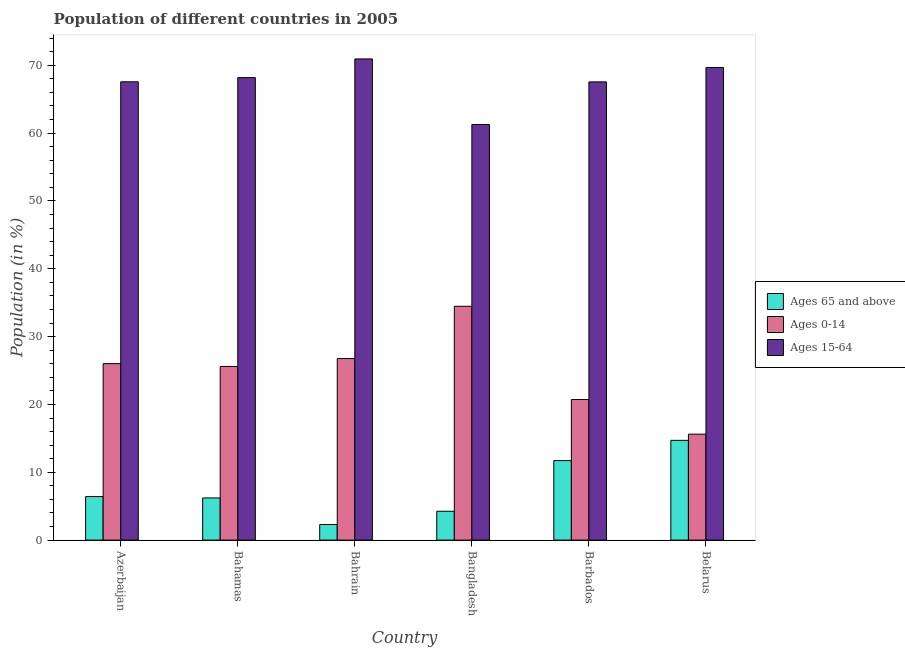How many different coloured bars are there?
Your answer should be very brief. 3. How many groups of bars are there?
Your answer should be compact. 6. Are the number of bars on each tick of the X-axis equal?
Your answer should be very brief. Yes. How many bars are there on the 3rd tick from the left?
Offer a terse response. 3. What is the label of the 1st group of bars from the left?
Keep it short and to the point. Azerbaijan. What is the percentage of population within the age-group 15-64 in Belarus?
Your response must be concise. 69.68. Across all countries, what is the maximum percentage of population within the age-group of 65 and above?
Your answer should be compact. 14.71. Across all countries, what is the minimum percentage of population within the age-group 0-14?
Make the answer very short. 15.62. In which country was the percentage of population within the age-group of 65 and above minimum?
Your answer should be compact. Bahrain. What is the total percentage of population within the age-group of 65 and above in the graph?
Provide a succinct answer. 45.62. What is the difference between the percentage of population within the age-group 0-14 in Bangladesh and that in Barbados?
Make the answer very short. 13.75. What is the difference between the percentage of population within the age-group of 65 and above in Bahamas and the percentage of population within the age-group 15-64 in Azerbaijan?
Your answer should be compact. -61.35. What is the average percentage of population within the age-group 15-64 per country?
Your answer should be very brief. 67.53. What is the difference between the percentage of population within the age-group of 65 and above and percentage of population within the age-group 0-14 in Barbados?
Give a very brief answer. -9.01. What is the ratio of the percentage of population within the age-group 0-14 in Bahamas to that in Belarus?
Provide a succinct answer. 1.64. Is the difference between the percentage of population within the age-group of 65 and above in Azerbaijan and Bangladesh greater than the difference between the percentage of population within the age-group 0-14 in Azerbaijan and Bangladesh?
Make the answer very short. Yes. What is the difference between the highest and the second highest percentage of population within the age-group of 65 and above?
Offer a very short reply. 2.99. What is the difference between the highest and the lowest percentage of population within the age-group of 65 and above?
Offer a very short reply. 12.41. In how many countries, is the percentage of population within the age-group 0-14 greater than the average percentage of population within the age-group 0-14 taken over all countries?
Offer a terse response. 4. Is the sum of the percentage of population within the age-group 15-64 in Azerbaijan and Bahamas greater than the maximum percentage of population within the age-group 0-14 across all countries?
Provide a short and direct response. Yes. What does the 2nd bar from the left in Bahamas represents?
Make the answer very short. Ages 0-14. What does the 1st bar from the right in Bangladesh represents?
Your answer should be compact. Ages 15-64. What is the difference between two consecutive major ticks on the Y-axis?
Give a very brief answer. 10. How are the legend labels stacked?
Offer a very short reply. Vertical. What is the title of the graph?
Offer a very short reply. Population of different countries in 2005. What is the label or title of the Y-axis?
Your answer should be compact. Population (in %). What is the Population (in %) of Ages 65 and above in Azerbaijan?
Offer a terse response. 6.42. What is the Population (in %) of Ages 0-14 in Azerbaijan?
Provide a short and direct response. 26.01. What is the Population (in %) of Ages 15-64 in Azerbaijan?
Keep it short and to the point. 67.57. What is the Population (in %) in Ages 65 and above in Bahamas?
Give a very brief answer. 6.22. What is the Population (in %) of Ages 0-14 in Bahamas?
Give a very brief answer. 25.6. What is the Population (in %) of Ages 15-64 in Bahamas?
Provide a short and direct response. 68.18. What is the Population (in %) in Ages 65 and above in Bahrain?
Keep it short and to the point. 2.3. What is the Population (in %) of Ages 0-14 in Bahrain?
Your response must be concise. 26.77. What is the Population (in %) in Ages 15-64 in Bahrain?
Offer a very short reply. 70.94. What is the Population (in %) in Ages 65 and above in Bangladesh?
Provide a short and direct response. 4.25. What is the Population (in %) of Ages 0-14 in Bangladesh?
Your answer should be compact. 34.47. What is the Population (in %) in Ages 15-64 in Bangladesh?
Ensure brevity in your answer.  61.27. What is the Population (in %) of Ages 65 and above in Barbados?
Provide a succinct answer. 11.72. What is the Population (in %) in Ages 0-14 in Barbados?
Ensure brevity in your answer.  20.73. What is the Population (in %) of Ages 15-64 in Barbados?
Give a very brief answer. 67.55. What is the Population (in %) in Ages 65 and above in Belarus?
Make the answer very short. 14.71. What is the Population (in %) in Ages 0-14 in Belarus?
Give a very brief answer. 15.62. What is the Population (in %) of Ages 15-64 in Belarus?
Offer a very short reply. 69.68. Across all countries, what is the maximum Population (in %) of Ages 65 and above?
Provide a succinct answer. 14.71. Across all countries, what is the maximum Population (in %) in Ages 0-14?
Provide a short and direct response. 34.47. Across all countries, what is the maximum Population (in %) in Ages 15-64?
Make the answer very short. 70.94. Across all countries, what is the minimum Population (in %) of Ages 65 and above?
Your response must be concise. 2.3. Across all countries, what is the minimum Population (in %) in Ages 0-14?
Your response must be concise. 15.62. Across all countries, what is the minimum Population (in %) in Ages 15-64?
Offer a terse response. 61.27. What is the total Population (in %) of Ages 65 and above in the graph?
Ensure brevity in your answer.  45.62. What is the total Population (in %) of Ages 0-14 in the graph?
Provide a succinct answer. 149.19. What is the total Population (in %) in Ages 15-64 in the graph?
Your answer should be compact. 405.19. What is the difference between the Population (in %) of Ages 65 and above in Azerbaijan and that in Bahamas?
Offer a very short reply. 0.2. What is the difference between the Population (in %) of Ages 0-14 in Azerbaijan and that in Bahamas?
Keep it short and to the point. 0.41. What is the difference between the Population (in %) of Ages 15-64 in Azerbaijan and that in Bahamas?
Make the answer very short. -0.62. What is the difference between the Population (in %) of Ages 65 and above in Azerbaijan and that in Bahrain?
Your answer should be very brief. 4.12. What is the difference between the Population (in %) of Ages 0-14 in Azerbaijan and that in Bahrain?
Give a very brief answer. -0.76. What is the difference between the Population (in %) in Ages 15-64 in Azerbaijan and that in Bahrain?
Give a very brief answer. -3.37. What is the difference between the Population (in %) in Ages 65 and above in Azerbaijan and that in Bangladesh?
Your answer should be very brief. 2.17. What is the difference between the Population (in %) of Ages 0-14 in Azerbaijan and that in Bangladesh?
Give a very brief answer. -8.46. What is the difference between the Population (in %) in Ages 15-64 in Azerbaijan and that in Bangladesh?
Offer a very short reply. 6.29. What is the difference between the Population (in %) of Ages 65 and above in Azerbaijan and that in Barbados?
Offer a terse response. -5.3. What is the difference between the Population (in %) of Ages 0-14 in Azerbaijan and that in Barbados?
Offer a very short reply. 5.28. What is the difference between the Population (in %) in Ages 15-64 in Azerbaijan and that in Barbados?
Offer a terse response. 0.01. What is the difference between the Population (in %) of Ages 65 and above in Azerbaijan and that in Belarus?
Give a very brief answer. -8.29. What is the difference between the Population (in %) of Ages 0-14 in Azerbaijan and that in Belarus?
Ensure brevity in your answer.  10.39. What is the difference between the Population (in %) of Ages 15-64 in Azerbaijan and that in Belarus?
Provide a short and direct response. -2.11. What is the difference between the Population (in %) of Ages 65 and above in Bahamas and that in Bahrain?
Offer a very short reply. 3.92. What is the difference between the Population (in %) in Ages 0-14 in Bahamas and that in Bahrain?
Give a very brief answer. -1.17. What is the difference between the Population (in %) in Ages 15-64 in Bahamas and that in Bahrain?
Ensure brevity in your answer.  -2.75. What is the difference between the Population (in %) of Ages 65 and above in Bahamas and that in Bangladesh?
Provide a short and direct response. 1.96. What is the difference between the Population (in %) of Ages 0-14 in Bahamas and that in Bangladesh?
Your response must be concise. -8.87. What is the difference between the Population (in %) of Ages 15-64 in Bahamas and that in Bangladesh?
Your response must be concise. 6.91. What is the difference between the Population (in %) of Ages 65 and above in Bahamas and that in Barbados?
Provide a succinct answer. -5.5. What is the difference between the Population (in %) of Ages 0-14 in Bahamas and that in Barbados?
Ensure brevity in your answer.  4.87. What is the difference between the Population (in %) in Ages 15-64 in Bahamas and that in Barbados?
Keep it short and to the point. 0.63. What is the difference between the Population (in %) in Ages 65 and above in Bahamas and that in Belarus?
Provide a short and direct response. -8.49. What is the difference between the Population (in %) in Ages 0-14 in Bahamas and that in Belarus?
Ensure brevity in your answer.  9.98. What is the difference between the Population (in %) in Ages 15-64 in Bahamas and that in Belarus?
Ensure brevity in your answer.  -1.49. What is the difference between the Population (in %) in Ages 65 and above in Bahrain and that in Bangladesh?
Offer a terse response. -1.96. What is the difference between the Population (in %) in Ages 0-14 in Bahrain and that in Bangladesh?
Your response must be concise. -7.71. What is the difference between the Population (in %) in Ages 15-64 in Bahrain and that in Bangladesh?
Keep it short and to the point. 9.66. What is the difference between the Population (in %) in Ages 65 and above in Bahrain and that in Barbados?
Make the answer very short. -9.42. What is the difference between the Population (in %) of Ages 0-14 in Bahrain and that in Barbados?
Your response must be concise. 6.04. What is the difference between the Population (in %) in Ages 15-64 in Bahrain and that in Barbados?
Your response must be concise. 3.38. What is the difference between the Population (in %) in Ages 65 and above in Bahrain and that in Belarus?
Offer a very short reply. -12.41. What is the difference between the Population (in %) of Ages 0-14 in Bahrain and that in Belarus?
Provide a short and direct response. 11.15. What is the difference between the Population (in %) of Ages 15-64 in Bahrain and that in Belarus?
Provide a short and direct response. 1.26. What is the difference between the Population (in %) in Ages 65 and above in Bangladesh and that in Barbados?
Provide a succinct answer. -7.47. What is the difference between the Population (in %) in Ages 0-14 in Bangladesh and that in Barbados?
Your response must be concise. 13.75. What is the difference between the Population (in %) of Ages 15-64 in Bangladesh and that in Barbados?
Provide a succinct answer. -6.28. What is the difference between the Population (in %) in Ages 65 and above in Bangladesh and that in Belarus?
Your response must be concise. -10.45. What is the difference between the Population (in %) of Ages 0-14 in Bangladesh and that in Belarus?
Give a very brief answer. 18.86. What is the difference between the Population (in %) in Ages 15-64 in Bangladesh and that in Belarus?
Give a very brief answer. -8.4. What is the difference between the Population (in %) in Ages 65 and above in Barbados and that in Belarus?
Provide a short and direct response. -2.99. What is the difference between the Population (in %) of Ages 0-14 in Barbados and that in Belarus?
Your answer should be very brief. 5.11. What is the difference between the Population (in %) of Ages 15-64 in Barbados and that in Belarus?
Ensure brevity in your answer.  -2.12. What is the difference between the Population (in %) of Ages 65 and above in Azerbaijan and the Population (in %) of Ages 0-14 in Bahamas?
Make the answer very short. -19.18. What is the difference between the Population (in %) in Ages 65 and above in Azerbaijan and the Population (in %) in Ages 15-64 in Bahamas?
Offer a very short reply. -61.76. What is the difference between the Population (in %) in Ages 0-14 in Azerbaijan and the Population (in %) in Ages 15-64 in Bahamas?
Make the answer very short. -42.17. What is the difference between the Population (in %) in Ages 65 and above in Azerbaijan and the Population (in %) in Ages 0-14 in Bahrain?
Give a very brief answer. -20.35. What is the difference between the Population (in %) in Ages 65 and above in Azerbaijan and the Population (in %) in Ages 15-64 in Bahrain?
Provide a succinct answer. -64.52. What is the difference between the Population (in %) of Ages 0-14 in Azerbaijan and the Population (in %) of Ages 15-64 in Bahrain?
Your answer should be compact. -44.93. What is the difference between the Population (in %) in Ages 65 and above in Azerbaijan and the Population (in %) in Ages 0-14 in Bangladesh?
Your answer should be very brief. -28.05. What is the difference between the Population (in %) of Ages 65 and above in Azerbaijan and the Population (in %) of Ages 15-64 in Bangladesh?
Your answer should be very brief. -54.85. What is the difference between the Population (in %) in Ages 0-14 in Azerbaijan and the Population (in %) in Ages 15-64 in Bangladesh?
Provide a succinct answer. -35.26. What is the difference between the Population (in %) of Ages 65 and above in Azerbaijan and the Population (in %) of Ages 0-14 in Barbados?
Provide a succinct answer. -14.31. What is the difference between the Population (in %) of Ages 65 and above in Azerbaijan and the Population (in %) of Ages 15-64 in Barbados?
Make the answer very short. -61.13. What is the difference between the Population (in %) in Ages 0-14 in Azerbaijan and the Population (in %) in Ages 15-64 in Barbados?
Keep it short and to the point. -41.54. What is the difference between the Population (in %) in Ages 65 and above in Azerbaijan and the Population (in %) in Ages 0-14 in Belarus?
Keep it short and to the point. -9.2. What is the difference between the Population (in %) in Ages 65 and above in Azerbaijan and the Population (in %) in Ages 15-64 in Belarus?
Ensure brevity in your answer.  -63.26. What is the difference between the Population (in %) of Ages 0-14 in Azerbaijan and the Population (in %) of Ages 15-64 in Belarus?
Provide a short and direct response. -43.67. What is the difference between the Population (in %) of Ages 65 and above in Bahamas and the Population (in %) of Ages 0-14 in Bahrain?
Ensure brevity in your answer.  -20.55. What is the difference between the Population (in %) of Ages 65 and above in Bahamas and the Population (in %) of Ages 15-64 in Bahrain?
Offer a very short reply. -64.72. What is the difference between the Population (in %) of Ages 0-14 in Bahamas and the Population (in %) of Ages 15-64 in Bahrain?
Offer a very short reply. -45.34. What is the difference between the Population (in %) of Ages 65 and above in Bahamas and the Population (in %) of Ages 0-14 in Bangladesh?
Make the answer very short. -28.26. What is the difference between the Population (in %) in Ages 65 and above in Bahamas and the Population (in %) in Ages 15-64 in Bangladesh?
Provide a short and direct response. -55.06. What is the difference between the Population (in %) of Ages 0-14 in Bahamas and the Population (in %) of Ages 15-64 in Bangladesh?
Offer a very short reply. -35.68. What is the difference between the Population (in %) in Ages 65 and above in Bahamas and the Population (in %) in Ages 0-14 in Barbados?
Your answer should be compact. -14.51. What is the difference between the Population (in %) of Ages 65 and above in Bahamas and the Population (in %) of Ages 15-64 in Barbados?
Your answer should be compact. -61.34. What is the difference between the Population (in %) in Ages 0-14 in Bahamas and the Population (in %) in Ages 15-64 in Barbados?
Your answer should be very brief. -41.95. What is the difference between the Population (in %) of Ages 65 and above in Bahamas and the Population (in %) of Ages 0-14 in Belarus?
Ensure brevity in your answer.  -9.4. What is the difference between the Population (in %) in Ages 65 and above in Bahamas and the Population (in %) in Ages 15-64 in Belarus?
Provide a short and direct response. -63.46. What is the difference between the Population (in %) of Ages 0-14 in Bahamas and the Population (in %) of Ages 15-64 in Belarus?
Offer a terse response. -44.08. What is the difference between the Population (in %) in Ages 65 and above in Bahrain and the Population (in %) in Ages 0-14 in Bangladesh?
Provide a succinct answer. -32.18. What is the difference between the Population (in %) in Ages 65 and above in Bahrain and the Population (in %) in Ages 15-64 in Bangladesh?
Offer a very short reply. -58.98. What is the difference between the Population (in %) of Ages 0-14 in Bahrain and the Population (in %) of Ages 15-64 in Bangladesh?
Offer a terse response. -34.51. What is the difference between the Population (in %) in Ages 65 and above in Bahrain and the Population (in %) in Ages 0-14 in Barbados?
Ensure brevity in your answer.  -18.43. What is the difference between the Population (in %) of Ages 65 and above in Bahrain and the Population (in %) of Ages 15-64 in Barbados?
Keep it short and to the point. -65.26. What is the difference between the Population (in %) of Ages 0-14 in Bahrain and the Population (in %) of Ages 15-64 in Barbados?
Offer a very short reply. -40.79. What is the difference between the Population (in %) in Ages 65 and above in Bahrain and the Population (in %) in Ages 0-14 in Belarus?
Keep it short and to the point. -13.32. What is the difference between the Population (in %) of Ages 65 and above in Bahrain and the Population (in %) of Ages 15-64 in Belarus?
Ensure brevity in your answer.  -67.38. What is the difference between the Population (in %) in Ages 0-14 in Bahrain and the Population (in %) in Ages 15-64 in Belarus?
Provide a succinct answer. -42.91. What is the difference between the Population (in %) in Ages 65 and above in Bangladesh and the Population (in %) in Ages 0-14 in Barbados?
Make the answer very short. -16.47. What is the difference between the Population (in %) of Ages 65 and above in Bangladesh and the Population (in %) of Ages 15-64 in Barbados?
Your response must be concise. -63.3. What is the difference between the Population (in %) in Ages 0-14 in Bangladesh and the Population (in %) in Ages 15-64 in Barbados?
Offer a very short reply. -33.08. What is the difference between the Population (in %) in Ages 65 and above in Bangladesh and the Population (in %) in Ages 0-14 in Belarus?
Provide a short and direct response. -11.36. What is the difference between the Population (in %) in Ages 65 and above in Bangladesh and the Population (in %) in Ages 15-64 in Belarus?
Ensure brevity in your answer.  -65.42. What is the difference between the Population (in %) of Ages 0-14 in Bangladesh and the Population (in %) of Ages 15-64 in Belarus?
Provide a succinct answer. -35.2. What is the difference between the Population (in %) of Ages 65 and above in Barbados and the Population (in %) of Ages 0-14 in Belarus?
Provide a succinct answer. -3.9. What is the difference between the Population (in %) in Ages 65 and above in Barbados and the Population (in %) in Ages 15-64 in Belarus?
Your answer should be very brief. -57.96. What is the difference between the Population (in %) of Ages 0-14 in Barbados and the Population (in %) of Ages 15-64 in Belarus?
Ensure brevity in your answer.  -48.95. What is the average Population (in %) in Ages 65 and above per country?
Your answer should be very brief. 7.6. What is the average Population (in %) of Ages 0-14 per country?
Offer a terse response. 24.87. What is the average Population (in %) of Ages 15-64 per country?
Ensure brevity in your answer.  67.53. What is the difference between the Population (in %) in Ages 65 and above and Population (in %) in Ages 0-14 in Azerbaijan?
Your answer should be compact. -19.59. What is the difference between the Population (in %) of Ages 65 and above and Population (in %) of Ages 15-64 in Azerbaijan?
Provide a succinct answer. -61.15. What is the difference between the Population (in %) of Ages 0-14 and Population (in %) of Ages 15-64 in Azerbaijan?
Offer a terse response. -41.56. What is the difference between the Population (in %) of Ages 65 and above and Population (in %) of Ages 0-14 in Bahamas?
Provide a succinct answer. -19.38. What is the difference between the Population (in %) in Ages 65 and above and Population (in %) in Ages 15-64 in Bahamas?
Your answer should be compact. -61.97. What is the difference between the Population (in %) of Ages 0-14 and Population (in %) of Ages 15-64 in Bahamas?
Keep it short and to the point. -42.59. What is the difference between the Population (in %) in Ages 65 and above and Population (in %) in Ages 0-14 in Bahrain?
Provide a succinct answer. -24.47. What is the difference between the Population (in %) of Ages 65 and above and Population (in %) of Ages 15-64 in Bahrain?
Provide a short and direct response. -68.64. What is the difference between the Population (in %) in Ages 0-14 and Population (in %) in Ages 15-64 in Bahrain?
Ensure brevity in your answer.  -44.17. What is the difference between the Population (in %) of Ages 65 and above and Population (in %) of Ages 0-14 in Bangladesh?
Offer a terse response. -30.22. What is the difference between the Population (in %) of Ages 65 and above and Population (in %) of Ages 15-64 in Bangladesh?
Your response must be concise. -57.02. What is the difference between the Population (in %) of Ages 0-14 and Population (in %) of Ages 15-64 in Bangladesh?
Your answer should be very brief. -26.8. What is the difference between the Population (in %) of Ages 65 and above and Population (in %) of Ages 0-14 in Barbados?
Offer a very short reply. -9.01. What is the difference between the Population (in %) in Ages 65 and above and Population (in %) in Ages 15-64 in Barbados?
Ensure brevity in your answer.  -55.83. What is the difference between the Population (in %) in Ages 0-14 and Population (in %) in Ages 15-64 in Barbados?
Offer a very short reply. -46.83. What is the difference between the Population (in %) of Ages 65 and above and Population (in %) of Ages 0-14 in Belarus?
Give a very brief answer. -0.91. What is the difference between the Population (in %) of Ages 65 and above and Population (in %) of Ages 15-64 in Belarus?
Offer a very short reply. -54.97. What is the difference between the Population (in %) in Ages 0-14 and Population (in %) in Ages 15-64 in Belarus?
Keep it short and to the point. -54.06. What is the ratio of the Population (in %) of Ages 65 and above in Azerbaijan to that in Bahamas?
Offer a terse response. 1.03. What is the ratio of the Population (in %) in Ages 0-14 in Azerbaijan to that in Bahamas?
Offer a very short reply. 1.02. What is the ratio of the Population (in %) of Ages 65 and above in Azerbaijan to that in Bahrain?
Give a very brief answer. 2.8. What is the ratio of the Population (in %) in Ages 0-14 in Azerbaijan to that in Bahrain?
Provide a succinct answer. 0.97. What is the ratio of the Population (in %) in Ages 15-64 in Azerbaijan to that in Bahrain?
Ensure brevity in your answer.  0.95. What is the ratio of the Population (in %) of Ages 65 and above in Azerbaijan to that in Bangladesh?
Offer a very short reply. 1.51. What is the ratio of the Population (in %) of Ages 0-14 in Azerbaijan to that in Bangladesh?
Give a very brief answer. 0.75. What is the ratio of the Population (in %) of Ages 15-64 in Azerbaijan to that in Bangladesh?
Make the answer very short. 1.1. What is the ratio of the Population (in %) of Ages 65 and above in Azerbaijan to that in Barbados?
Ensure brevity in your answer.  0.55. What is the ratio of the Population (in %) in Ages 0-14 in Azerbaijan to that in Barbados?
Provide a short and direct response. 1.25. What is the ratio of the Population (in %) of Ages 15-64 in Azerbaijan to that in Barbados?
Ensure brevity in your answer.  1. What is the ratio of the Population (in %) of Ages 65 and above in Azerbaijan to that in Belarus?
Keep it short and to the point. 0.44. What is the ratio of the Population (in %) in Ages 0-14 in Azerbaijan to that in Belarus?
Your answer should be compact. 1.67. What is the ratio of the Population (in %) in Ages 15-64 in Azerbaijan to that in Belarus?
Your answer should be compact. 0.97. What is the ratio of the Population (in %) in Ages 65 and above in Bahamas to that in Bahrain?
Keep it short and to the point. 2.71. What is the ratio of the Population (in %) of Ages 0-14 in Bahamas to that in Bahrain?
Provide a short and direct response. 0.96. What is the ratio of the Population (in %) in Ages 15-64 in Bahamas to that in Bahrain?
Your response must be concise. 0.96. What is the ratio of the Population (in %) of Ages 65 and above in Bahamas to that in Bangladesh?
Make the answer very short. 1.46. What is the ratio of the Population (in %) of Ages 0-14 in Bahamas to that in Bangladesh?
Your answer should be compact. 0.74. What is the ratio of the Population (in %) in Ages 15-64 in Bahamas to that in Bangladesh?
Provide a short and direct response. 1.11. What is the ratio of the Population (in %) in Ages 65 and above in Bahamas to that in Barbados?
Provide a succinct answer. 0.53. What is the ratio of the Population (in %) of Ages 0-14 in Bahamas to that in Barbados?
Your answer should be very brief. 1.24. What is the ratio of the Population (in %) in Ages 15-64 in Bahamas to that in Barbados?
Your answer should be very brief. 1.01. What is the ratio of the Population (in %) of Ages 65 and above in Bahamas to that in Belarus?
Provide a short and direct response. 0.42. What is the ratio of the Population (in %) of Ages 0-14 in Bahamas to that in Belarus?
Ensure brevity in your answer.  1.64. What is the ratio of the Population (in %) of Ages 15-64 in Bahamas to that in Belarus?
Provide a short and direct response. 0.98. What is the ratio of the Population (in %) of Ages 65 and above in Bahrain to that in Bangladesh?
Offer a very short reply. 0.54. What is the ratio of the Population (in %) of Ages 0-14 in Bahrain to that in Bangladesh?
Keep it short and to the point. 0.78. What is the ratio of the Population (in %) of Ages 15-64 in Bahrain to that in Bangladesh?
Ensure brevity in your answer.  1.16. What is the ratio of the Population (in %) in Ages 65 and above in Bahrain to that in Barbados?
Keep it short and to the point. 0.2. What is the ratio of the Population (in %) in Ages 0-14 in Bahrain to that in Barbados?
Keep it short and to the point. 1.29. What is the ratio of the Population (in %) of Ages 15-64 in Bahrain to that in Barbados?
Keep it short and to the point. 1.05. What is the ratio of the Population (in %) in Ages 65 and above in Bahrain to that in Belarus?
Offer a very short reply. 0.16. What is the ratio of the Population (in %) of Ages 0-14 in Bahrain to that in Belarus?
Ensure brevity in your answer.  1.71. What is the ratio of the Population (in %) of Ages 15-64 in Bahrain to that in Belarus?
Offer a terse response. 1.02. What is the ratio of the Population (in %) in Ages 65 and above in Bangladesh to that in Barbados?
Give a very brief answer. 0.36. What is the ratio of the Population (in %) in Ages 0-14 in Bangladesh to that in Barbados?
Give a very brief answer. 1.66. What is the ratio of the Population (in %) of Ages 15-64 in Bangladesh to that in Barbados?
Offer a very short reply. 0.91. What is the ratio of the Population (in %) of Ages 65 and above in Bangladesh to that in Belarus?
Your response must be concise. 0.29. What is the ratio of the Population (in %) in Ages 0-14 in Bangladesh to that in Belarus?
Offer a terse response. 2.21. What is the ratio of the Population (in %) in Ages 15-64 in Bangladesh to that in Belarus?
Your answer should be very brief. 0.88. What is the ratio of the Population (in %) of Ages 65 and above in Barbados to that in Belarus?
Offer a very short reply. 0.8. What is the ratio of the Population (in %) in Ages 0-14 in Barbados to that in Belarus?
Offer a terse response. 1.33. What is the ratio of the Population (in %) of Ages 15-64 in Barbados to that in Belarus?
Your response must be concise. 0.97. What is the difference between the highest and the second highest Population (in %) in Ages 65 and above?
Make the answer very short. 2.99. What is the difference between the highest and the second highest Population (in %) of Ages 0-14?
Offer a very short reply. 7.71. What is the difference between the highest and the second highest Population (in %) in Ages 15-64?
Ensure brevity in your answer.  1.26. What is the difference between the highest and the lowest Population (in %) of Ages 65 and above?
Give a very brief answer. 12.41. What is the difference between the highest and the lowest Population (in %) in Ages 0-14?
Your answer should be compact. 18.86. What is the difference between the highest and the lowest Population (in %) in Ages 15-64?
Provide a short and direct response. 9.66. 